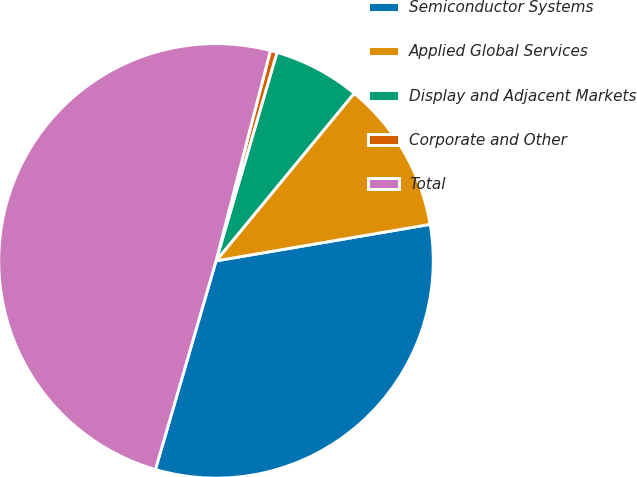Convert chart. <chart><loc_0><loc_0><loc_500><loc_500><pie_chart><fcel>Semiconductor Systems<fcel>Applied Global Services<fcel>Display and Adjacent Markets<fcel>Corporate and Other<fcel>Total<nl><fcel>32.19%<fcel>11.34%<fcel>6.44%<fcel>0.5%<fcel>49.53%<nl></chart> 